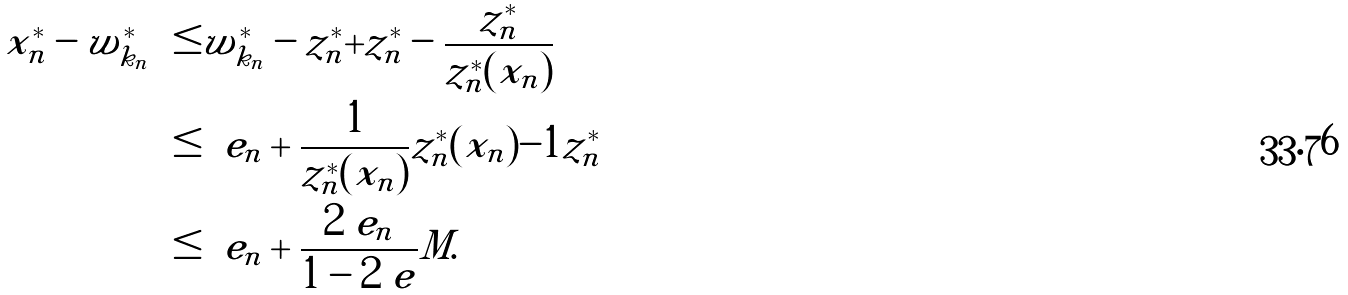Convert formula to latex. <formula><loc_0><loc_0><loc_500><loc_500>\| x _ { n } ^ { * } - w _ { k _ { n } } ^ { * } \| & \leq \| w _ { k _ { n } } ^ { * } - z _ { n } ^ { * } \| + \| z _ { n } ^ { * } - \frac { z _ { n } ^ { * } } { z _ { n } ^ { * } ( x _ { n } ) } \| \\ & \leq \ e _ { n } + \frac { 1 } { z _ { n } ^ { * } ( x _ { n } ) } | z _ { n } ^ { * } ( x _ { n } ) - 1 | \| z _ { n } ^ { * } \| \\ & \leq \ e _ { n } + \frac { 2 \ e _ { n } } { 1 - 2 \ e } M .</formula> 